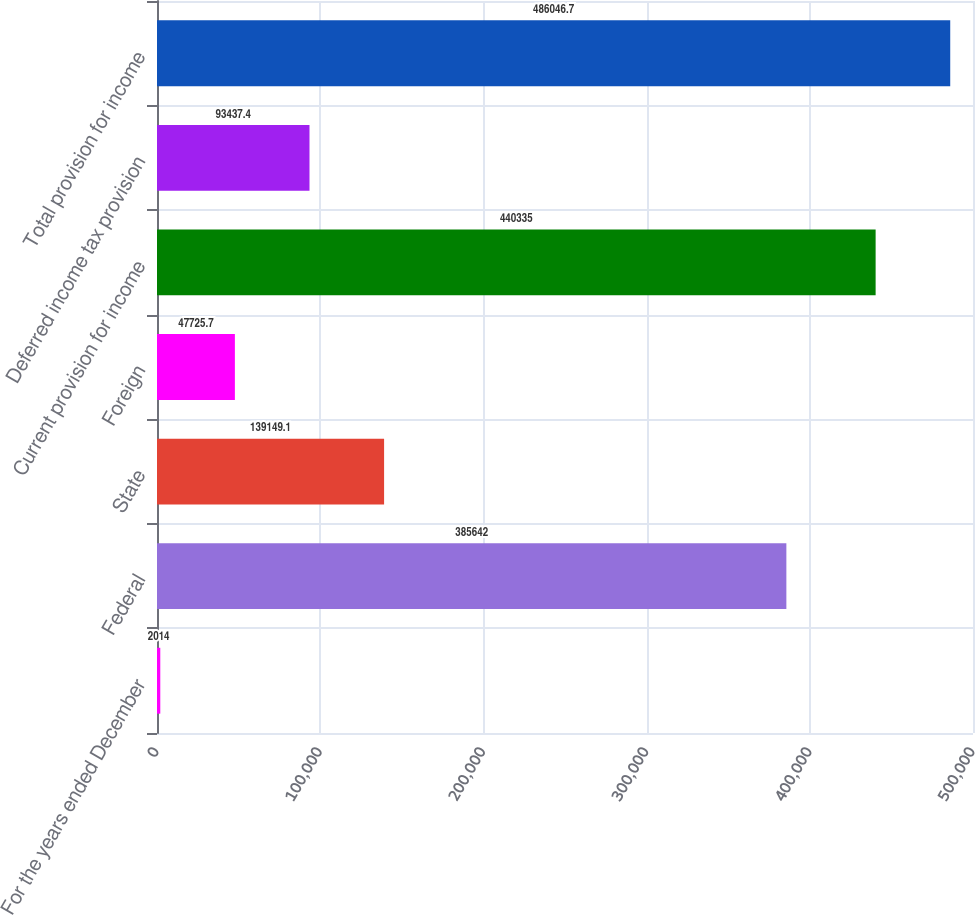Convert chart. <chart><loc_0><loc_0><loc_500><loc_500><bar_chart><fcel>For the years ended December<fcel>Federal<fcel>State<fcel>Foreign<fcel>Current provision for income<fcel>Deferred income tax provision<fcel>Total provision for income<nl><fcel>2014<fcel>385642<fcel>139149<fcel>47725.7<fcel>440335<fcel>93437.4<fcel>486047<nl></chart> 